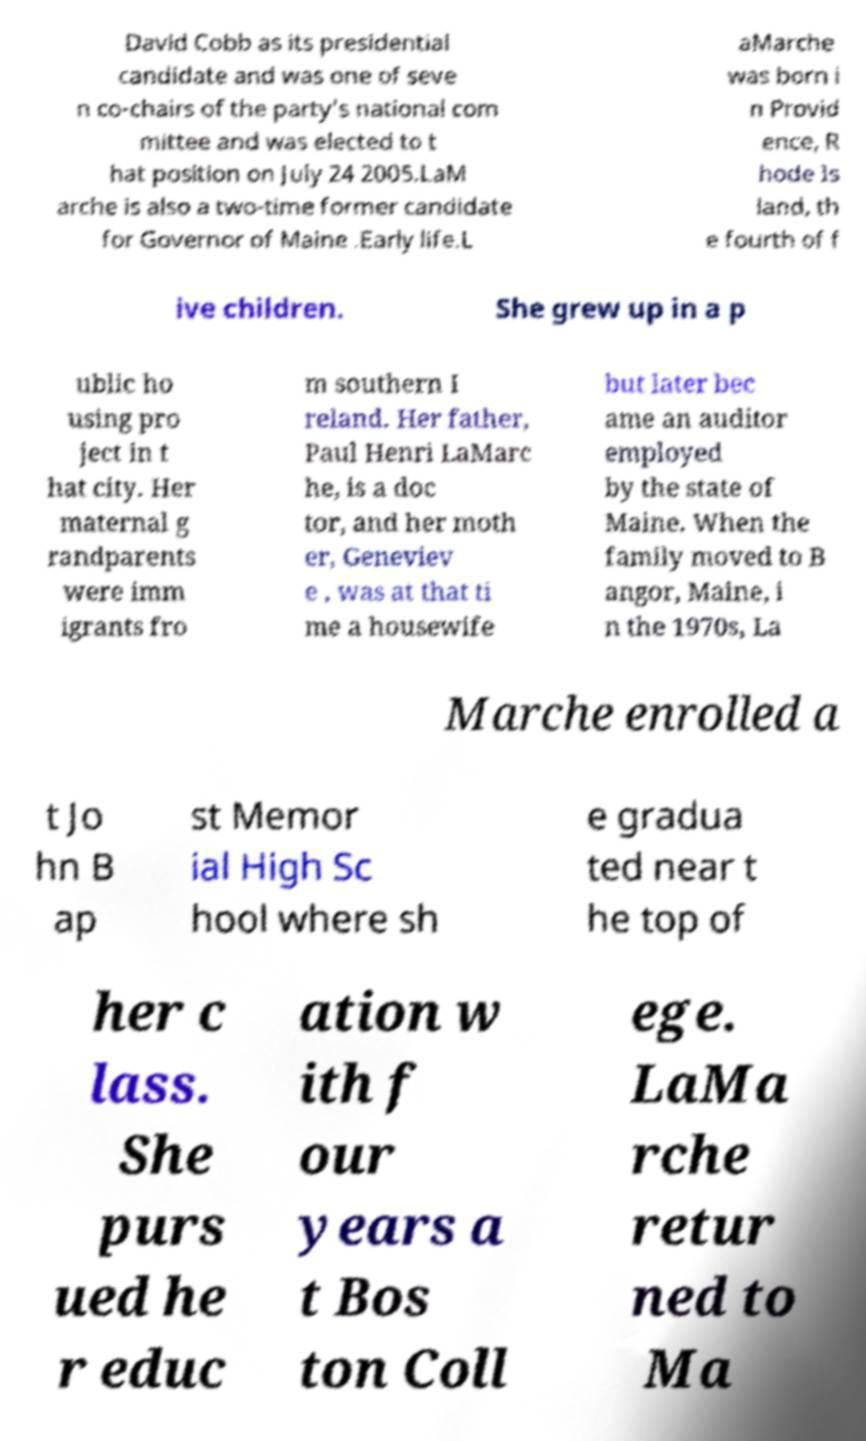Can you read and provide the text displayed in the image?This photo seems to have some interesting text. Can you extract and type it out for me? David Cobb as its presidential candidate and was one of seve n co-chairs of the party’s national com mittee and was elected to t hat position on July 24 2005.LaM arche is also a two-time former candidate for Governor of Maine .Early life.L aMarche was born i n Provid ence, R hode Is land, th e fourth of f ive children. She grew up in a p ublic ho using pro ject in t hat city. Her maternal g randparents were imm igrants fro m southern I reland. Her father, Paul Henri LaMarc he, is a doc tor, and her moth er, Geneviev e , was at that ti me a housewife but later bec ame an auditor employed by the state of Maine. When the family moved to B angor, Maine, i n the 1970s, La Marche enrolled a t Jo hn B ap st Memor ial High Sc hool where sh e gradua ted near t he top of her c lass. She purs ued he r educ ation w ith f our years a t Bos ton Coll ege. LaMa rche retur ned to Ma 